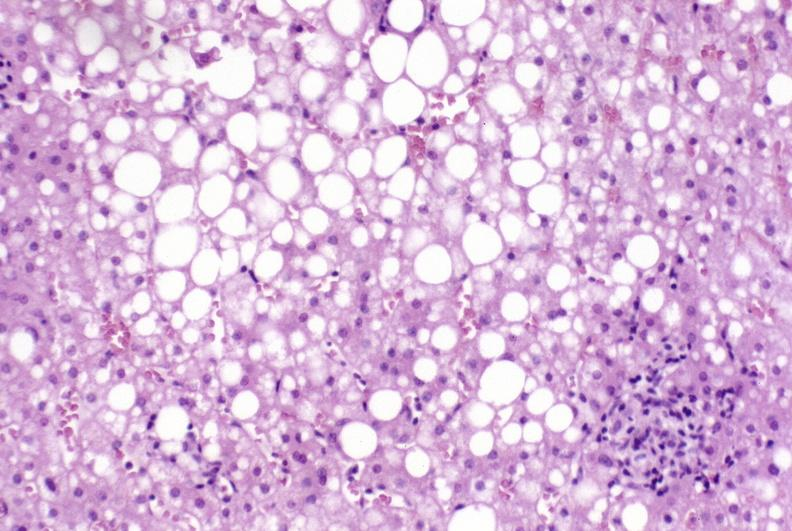what is present?
Answer the question using a single word or phrase. Liver 